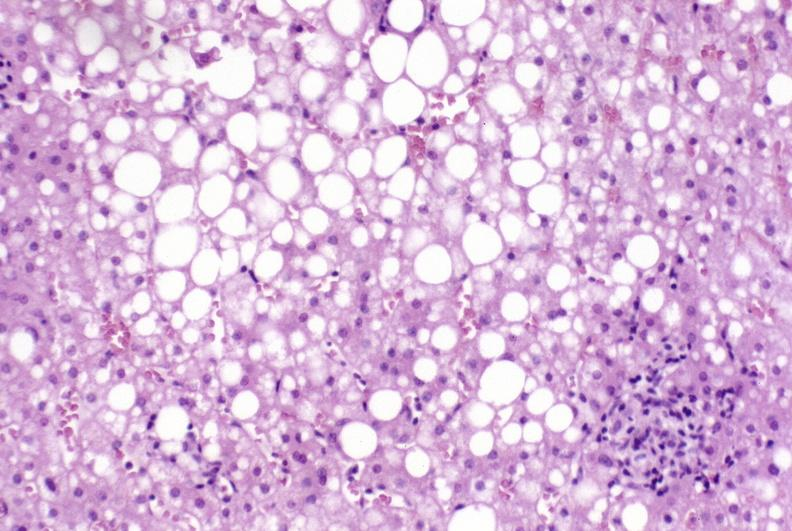what is present?
Answer the question using a single word or phrase. Liver 